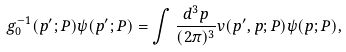Convert formula to latex. <formula><loc_0><loc_0><loc_500><loc_500>g ^ { - 1 } _ { 0 } ( { p } ^ { \prime } ; P ) \psi ( { p } ^ { \prime } ; P ) = \int \frac { d ^ { 3 } p } { ( 2 \pi ) ^ { 3 } } v ( { p } ^ { \prime } , { p } ; P ) \psi ( { p } ; P ) ,</formula> 